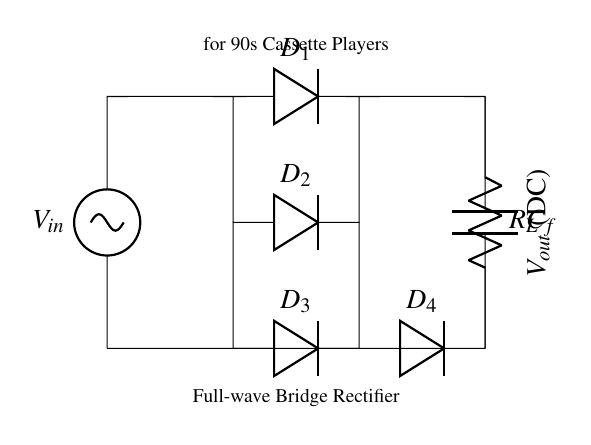What is the input voltage of the circuit? The input voltage is denoted as V_in, which is the voltage supplied to the rectifier. It is shown at the top left of the circuit diagram.
Answer: V_in How many diodes are used in this rectifier circuit? There are four diodes in the circuit (D_1, D_2, D_3, and D_4), which are essential for the full-wave bridge rectification. They are visibly marked in the diagram.
Answer: 4 What is the purpose of the capacitor labeled C_f? The capacitor C_f is used for filtering the output to smooth the DC voltage. It helps to reduce voltage ripple from the rectified output.
Answer: Filtering Which component provides the load resistance in this circuit? The resistor R_L represents the load resistance in this circuit and is connected at the output of the bridge rectifier, indicating the component the rectified voltage powers.
Answer: R_L What type of rectification does this circuit perform? This circuit configuration performs full-wave rectification, as indicated by the four diodes arranged in a bridge configuration allowing current to pass during both halves of the input waveform.
Answer: Full-wave What is the output voltage type in this circuit? The output voltage is DC, as indicated at the output node, which represents the direct current voltage after rectification.
Answer: DC Why is this circuit designed specifically for 90s cassette players? This circuit is designed for 90s cassette players to provide the appropriate DC voltage required for their operation, ensuring compatibility with the vintage technology of that era.
Answer: Vintage compatibility 